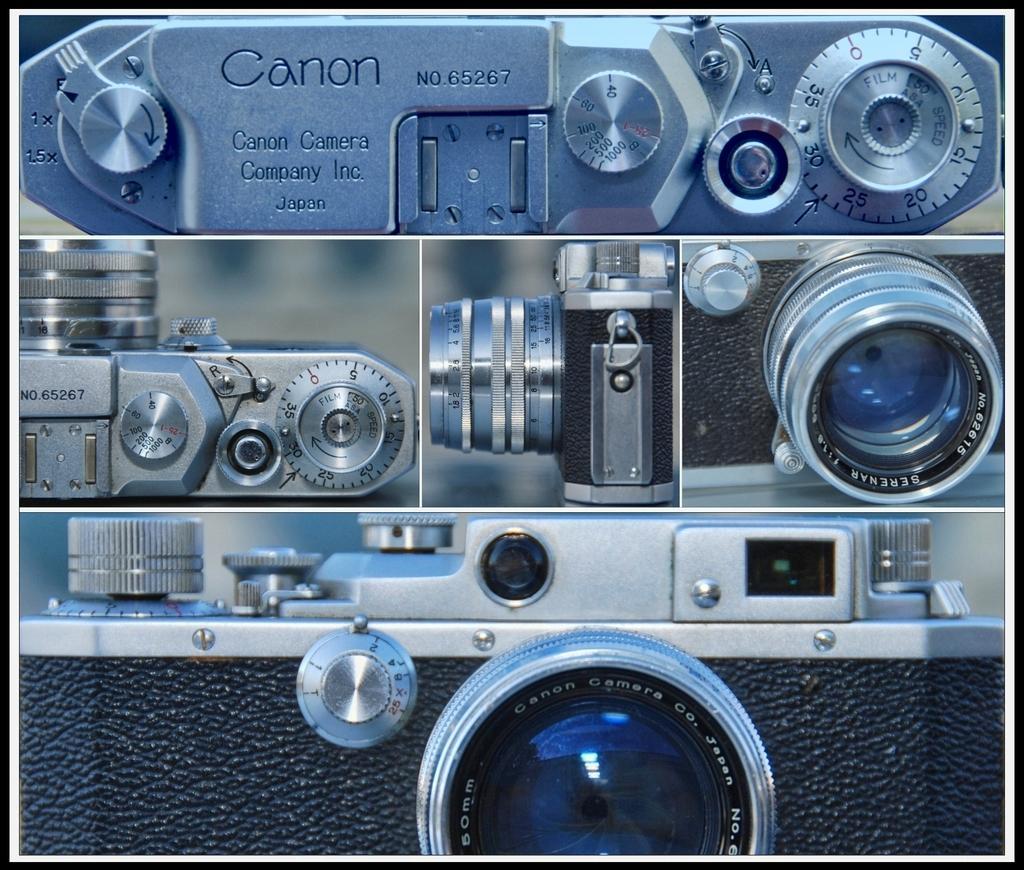How would you summarize this image in a sentence or two? In this image there is a canon camera with different lens. 